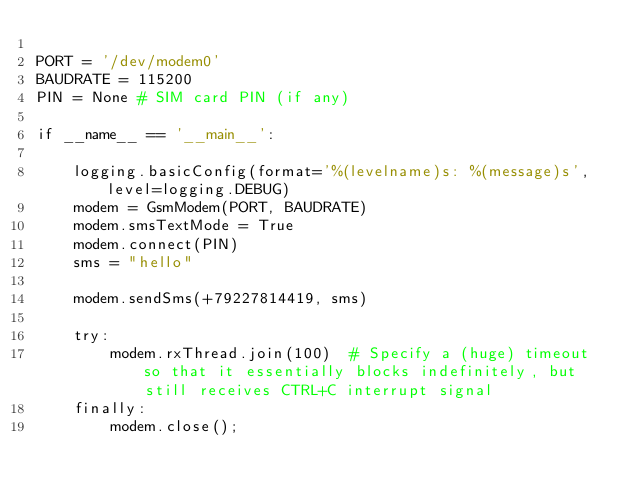<code> <loc_0><loc_0><loc_500><loc_500><_Python_>
PORT = '/dev/modem0'
BAUDRATE = 115200
PIN = None # SIM card PIN (if any)

if __name__ == '__main__':

    logging.basicConfig(format='%(levelname)s: %(message)s', level=logging.DEBUG)
    modem = GsmModem(PORT, BAUDRATE)
    modem.smsTextMode = True
    modem.connect(PIN)
    sms = "hello"

    modem.sendSms(+79227814419, sms)

    try:
        modem.rxThread.join(100)  # Specify a (huge) timeout so that it essentially blocks indefinitely, but still receives CTRL+C interrupt signal
    finally:
        modem.close();</code> 